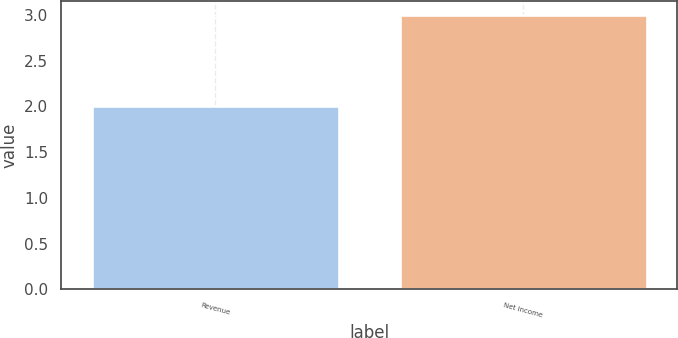Convert chart to OTSL. <chart><loc_0><loc_0><loc_500><loc_500><bar_chart><fcel>Revenue<fcel>Net income<nl><fcel>2<fcel>3<nl></chart> 